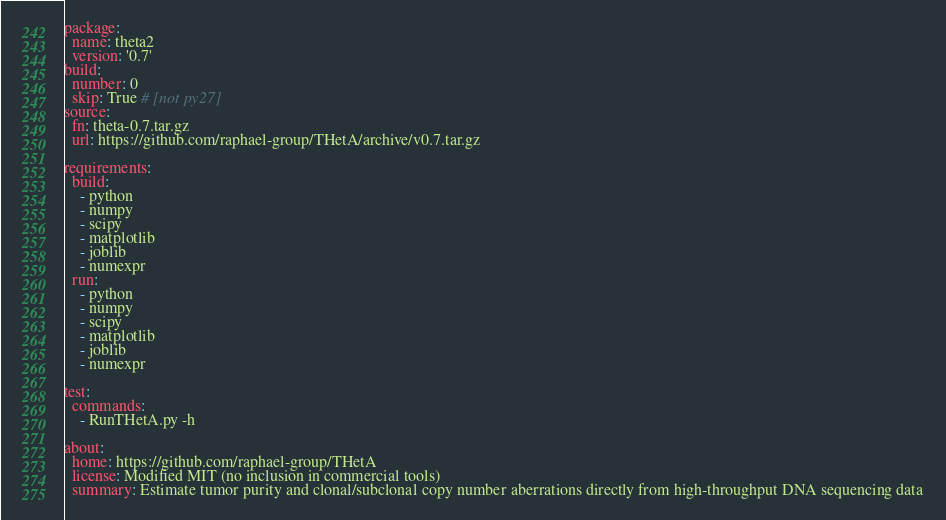<code> <loc_0><loc_0><loc_500><loc_500><_YAML_>package:
  name: theta2
  version: '0.7'
build:
  number: 0
  skip: True # [not py27]
source:
  fn: theta-0.7.tar.gz
  url: https://github.com/raphael-group/THetA/archive/v0.7.tar.gz

requirements:
  build:
    - python
    - numpy
    - scipy
    - matplotlib
    - joblib
    - numexpr
  run:
    - python
    - numpy
    - scipy
    - matplotlib
    - joblib
    - numexpr

test:
  commands:
    - RunTHetA.py -h

about:
  home: https://github.com/raphael-group/THetA
  license: Modified MIT (no inclusion in commercial tools)
  summary: Estimate tumor purity and clonal/subclonal copy number aberrations directly from high-throughput DNA sequencing data
</code> 